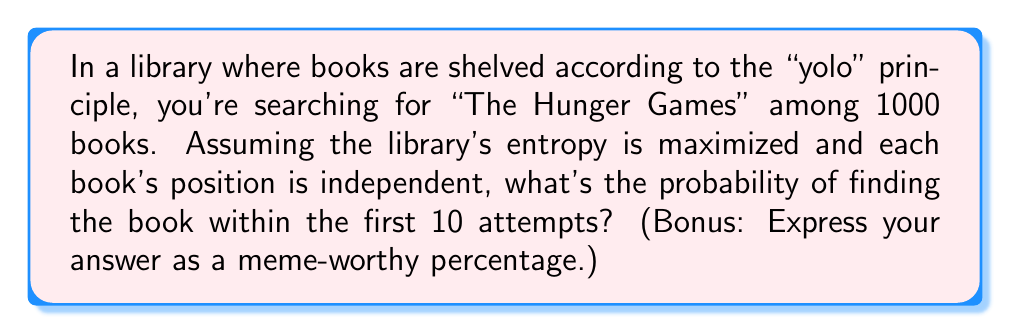Provide a solution to this math problem. Let's approach this problem using statistical mechanics and probability theory:

1. Define the system:
   - Total number of books: $N = 1000$
   - Number of search attempts: $k = 10$
   - We're looking for one specific book

2. Calculate the probability of not finding the book in a single attempt:
   $p(\text{not finding}) = \frac{999}{1000} = 0.999$

3. Probability of not finding the book in 10 attempts:
   $P(\text{not finding in 10 attempts}) = (0.999)^{10} \approx 0.9900$

4. Probability of finding the book within 10 attempts:
   $P(\text{finding}) = 1 - P(\text{not finding in 10 attempts})$
   $P(\text{finding}) = 1 - 0.9900 \approx 0.0100$

5. Convert to percentage:
   $0.0100 \times 100\% = 1\%$

6. Make it meme-worthy:
   Round to the nearest whole number and add a "%" symbol.

The probability is low because the library's high entropy (chaos) makes it difficult to locate a specific book quickly.
Answer: 1% (AKA "Success rate: me trying to adult") 